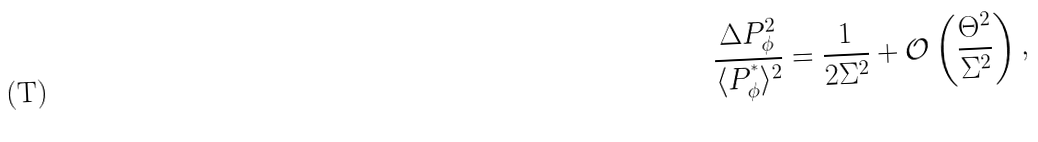<formula> <loc_0><loc_0><loc_500><loc_500>\frac { \Delta P _ { \phi } ^ { 2 } } { \langle P ^ { ^ { * } } _ { \phi } \rangle ^ { 2 } } = \frac { 1 } { 2 \Sigma ^ { 2 } } + \mathcal { O } \left ( \frac { \Theta ^ { 2 } } { \Sigma ^ { 2 } } \right ) ,</formula> 